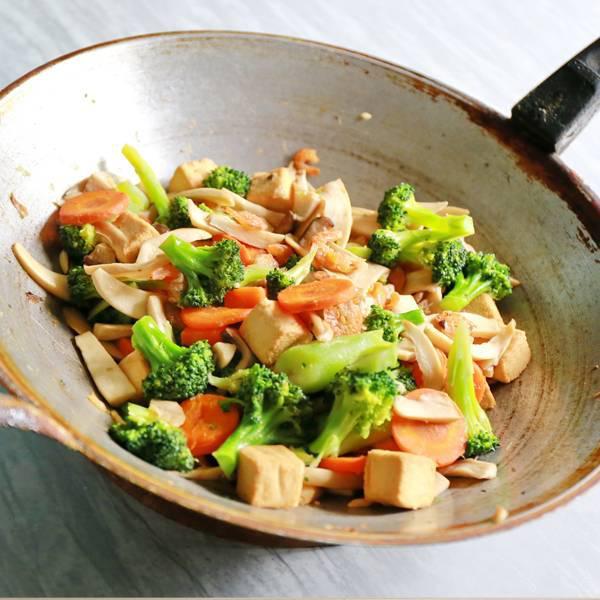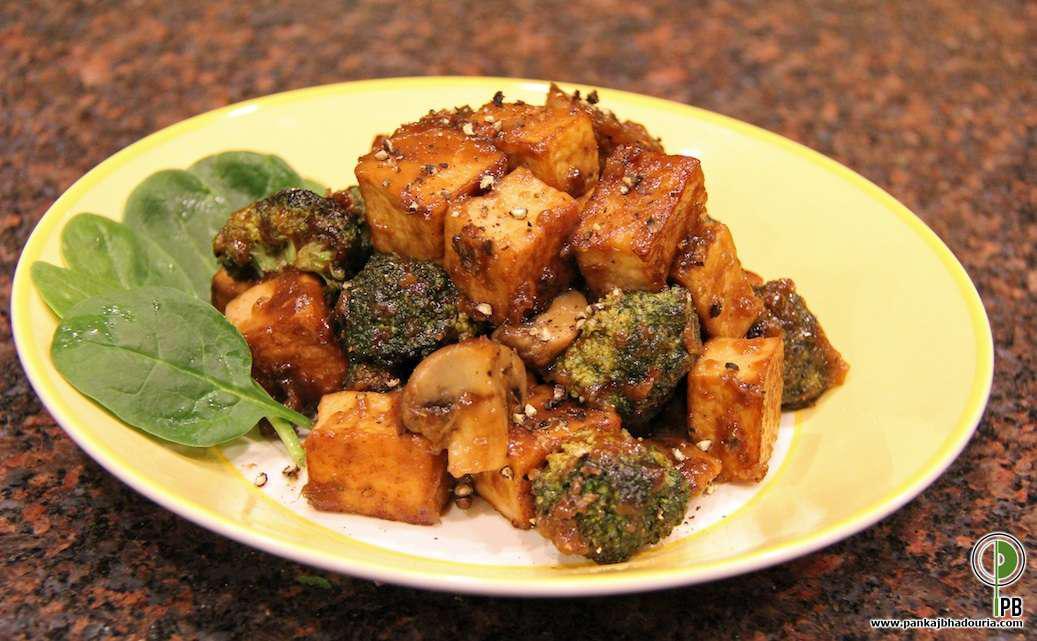The first image is the image on the left, the second image is the image on the right. For the images displayed, is the sentence "At least one image shows a broccoli dish served on an all white plate, with no colored trim." factually correct? Answer yes or no. No. The first image is the image on the left, the second image is the image on the right. Assess this claim about the two images: "There is rice in the image on the right.". Correct or not? Answer yes or no. No. 